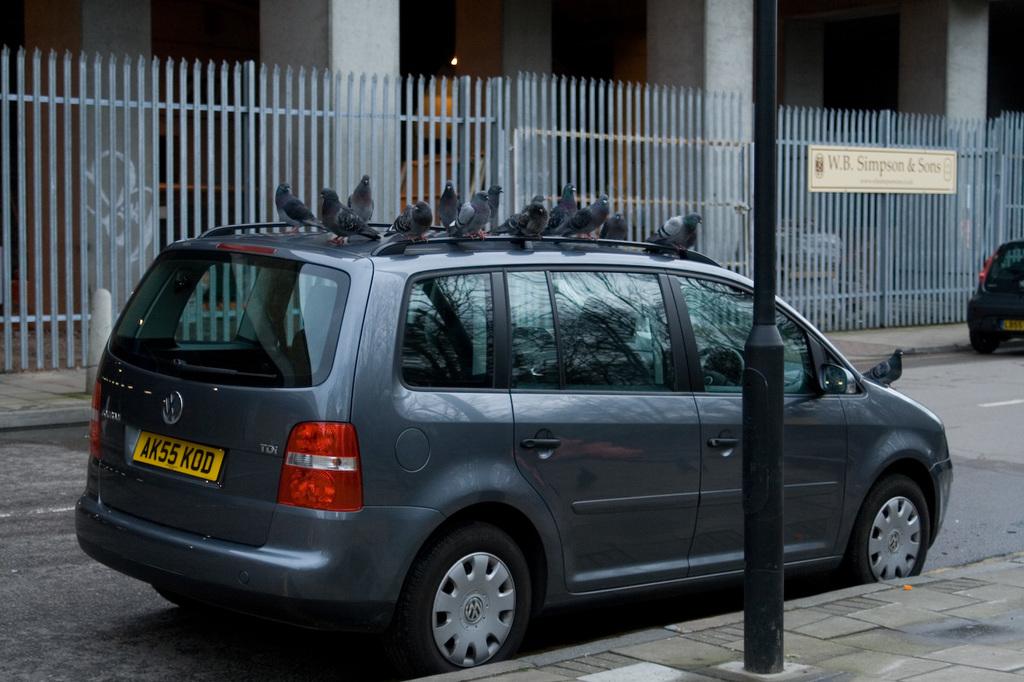What are the initials before simpson and sons on the sign?
Provide a short and direct response. W.b. What does the license plate say on vehicle?
Your response must be concise. Ak55 kod. 